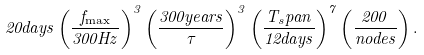Convert formula to latex. <formula><loc_0><loc_0><loc_500><loc_500>2 0 d a y s \left ( \frac { f _ { \max } } { 3 0 0 H z } \right ) ^ { 3 } \left ( \frac { 3 0 0 y e a r s } { \tau } \right ) ^ { 3 } \left ( \frac { T _ { s } p a n } { 1 2 d a y s } \right ) ^ { 7 } \left ( \frac { 2 0 0 } { n o d e s } \right ) .</formula> 